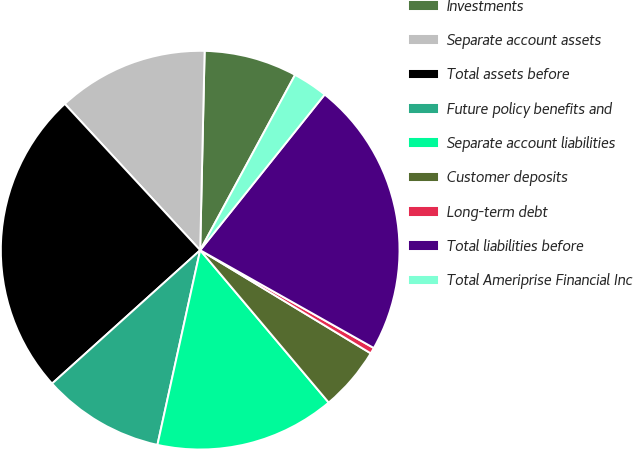Convert chart. <chart><loc_0><loc_0><loc_500><loc_500><pie_chart><fcel>Investments<fcel>Separate account assets<fcel>Total assets before<fcel>Future policy benefits and<fcel>Separate account liabilities<fcel>Customer deposits<fcel>Long-term debt<fcel>Total liabilities before<fcel>Total Ameriprise Financial Inc<nl><fcel>7.54%<fcel>12.24%<fcel>24.78%<fcel>9.89%<fcel>14.59%<fcel>5.19%<fcel>0.49%<fcel>22.43%<fcel>2.84%<nl></chart> 